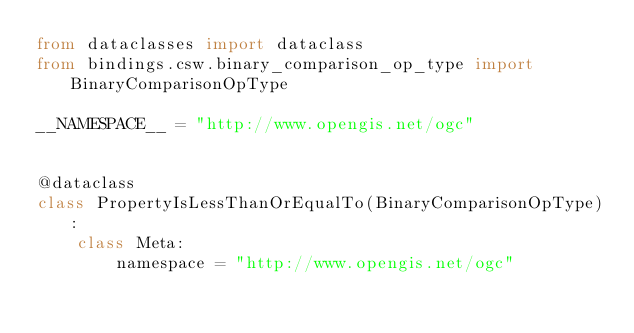Convert code to text. <code><loc_0><loc_0><loc_500><loc_500><_Python_>from dataclasses import dataclass
from bindings.csw.binary_comparison_op_type import BinaryComparisonOpType

__NAMESPACE__ = "http://www.opengis.net/ogc"


@dataclass
class PropertyIsLessThanOrEqualTo(BinaryComparisonOpType):
    class Meta:
        namespace = "http://www.opengis.net/ogc"
</code> 